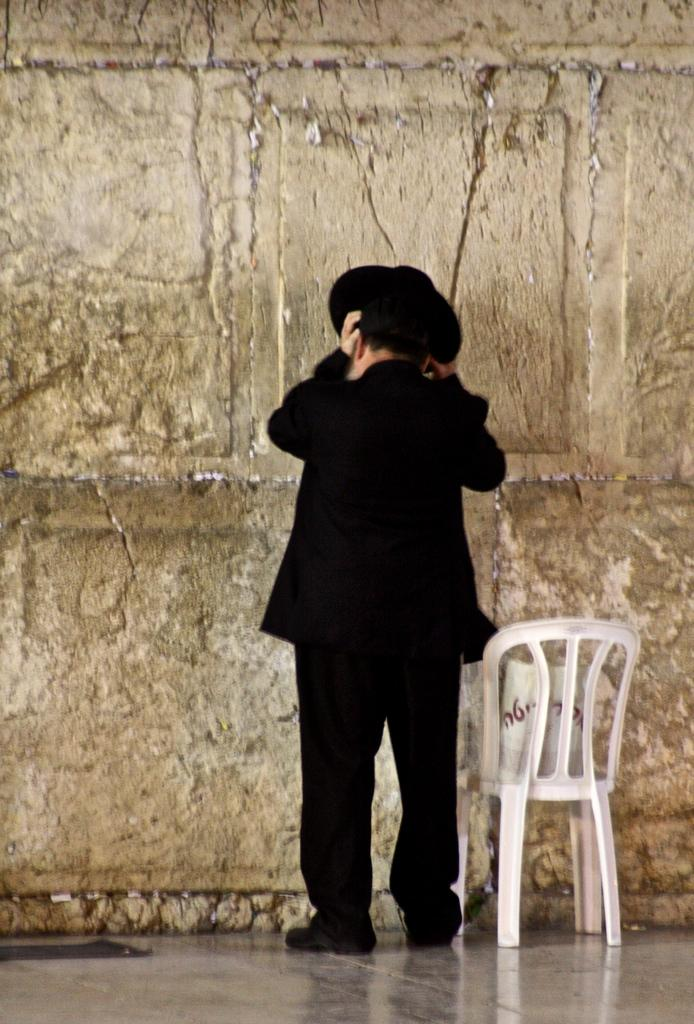Who is present in the image? There is a man in the image. What is the man wearing? The man is wearing a black dress and a black hat. What object is located beside the man? There is a chair beside the man. What is in front of the man? There is a wall in front of the man. What type of cows can be seen teaching in the image? There are no cows or teaching activities present in the image. 